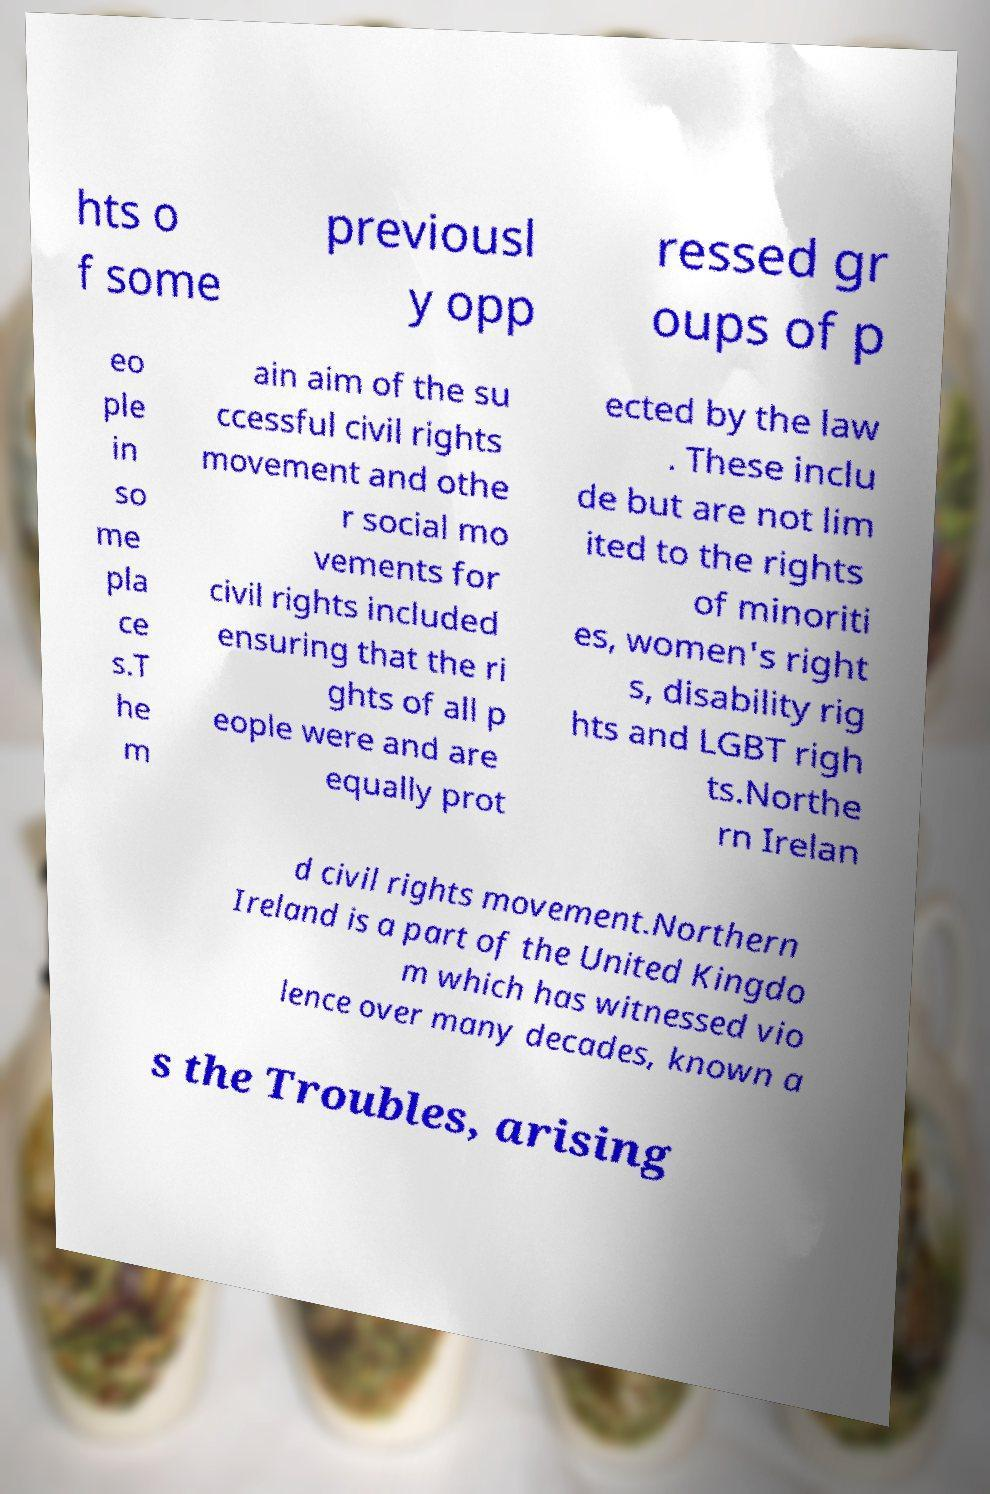What messages or text are displayed in this image? I need them in a readable, typed format. hts o f some previousl y opp ressed gr oups of p eo ple in so me pla ce s.T he m ain aim of the su ccessful civil rights movement and othe r social mo vements for civil rights included ensuring that the ri ghts of all p eople were and are equally prot ected by the law . These inclu de but are not lim ited to the rights of minoriti es, women's right s, disability rig hts and LGBT righ ts.Northe rn Irelan d civil rights movement.Northern Ireland is a part of the United Kingdo m which has witnessed vio lence over many decades, known a s the Troubles, arising 